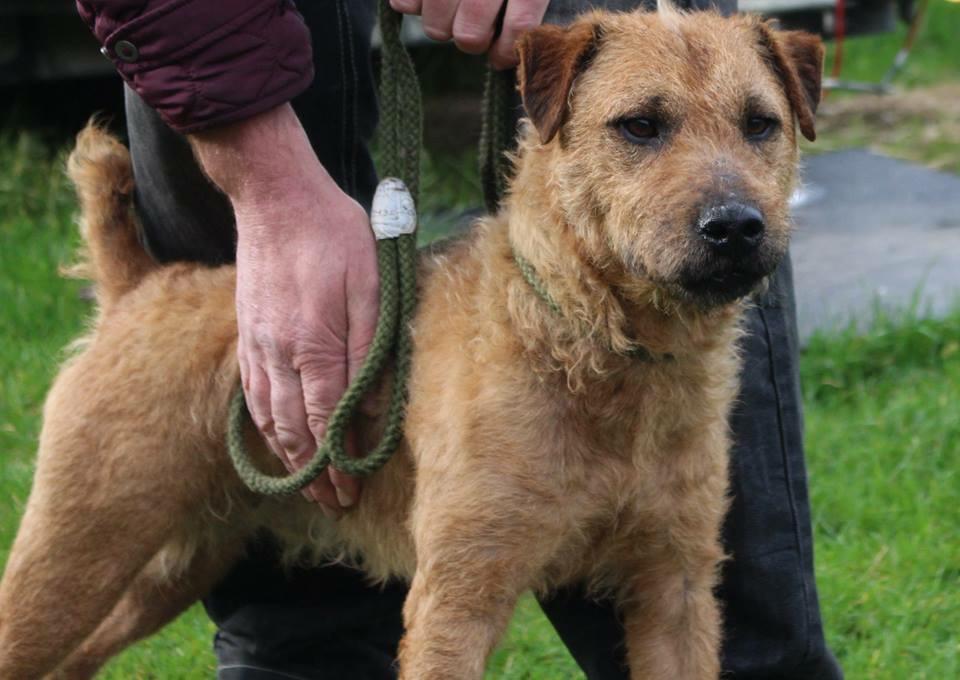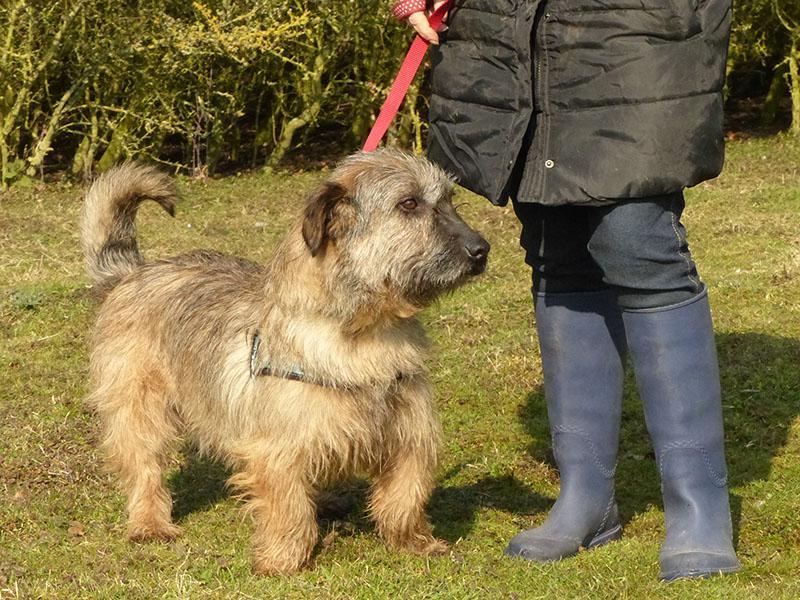The first image is the image on the left, the second image is the image on the right. Assess this claim about the two images: "There are two dogs total outside in the grass.". Correct or not? Answer yes or no. Yes. The first image is the image on the left, the second image is the image on the right. Analyze the images presented: Is the assertion "The dogs are inside." valid? Answer yes or no. No. 